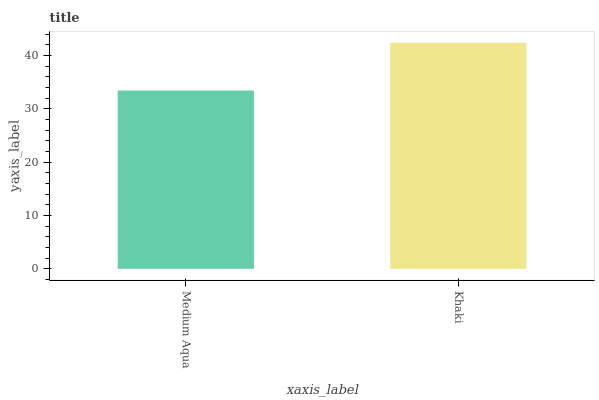Is Medium Aqua the minimum?
Answer yes or no. Yes. Is Khaki the maximum?
Answer yes or no. Yes. Is Khaki the minimum?
Answer yes or no. No. Is Khaki greater than Medium Aqua?
Answer yes or no. Yes. Is Medium Aqua less than Khaki?
Answer yes or no. Yes. Is Medium Aqua greater than Khaki?
Answer yes or no. No. Is Khaki less than Medium Aqua?
Answer yes or no. No. Is Khaki the high median?
Answer yes or no. Yes. Is Medium Aqua the low median?
Answer yes or no. Yes. Is Medium Aqua the high median?
Answer yes or no. No. Is Khaki the low median?
Answer yes or no. No. 